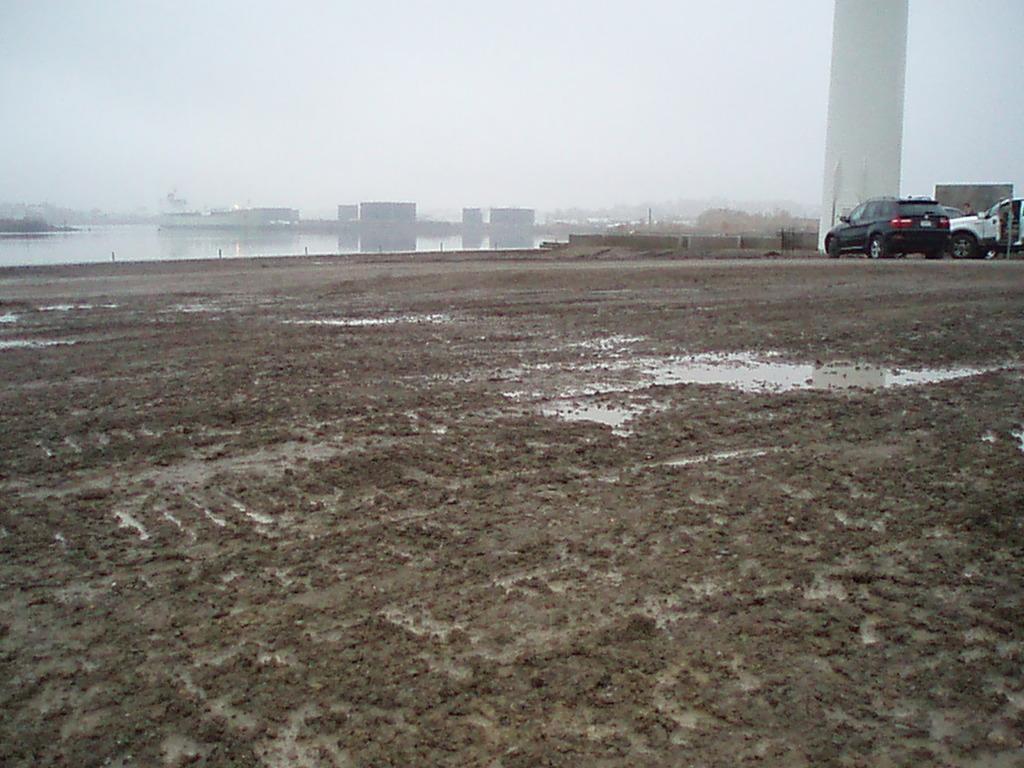In one or two sentences, can you explain what this image depicts? In this picture we can observe some mud. We can observe water here. On the right side there are some cars parked. We can observe white color pillar here. There is a river. In the background there is a sky. 